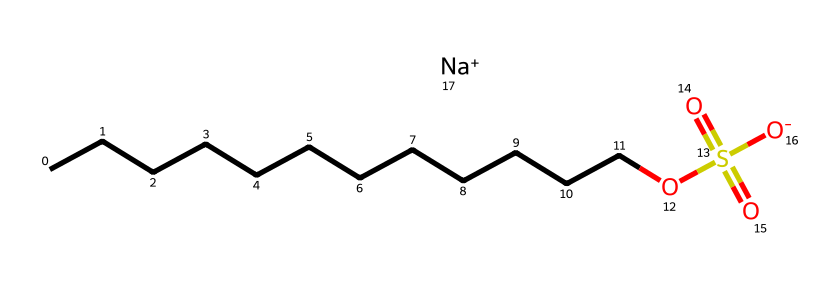What is the name of this chemical? The SMILES representation indicates that the chemical consists of a long carbon chain with a sulfate group and sodium ion. This structure corresponds to sodium lauryl sulfate, commonly used as a foaming agent in cosmetics.
Answer: sodium lauryl sulfate How many carbon atoms are in this molecule? By analyzing the carbon chain in the SMILES, we can count the number of 'C' symbols present in the longest chain, which totals to 12 carbon atoms in sodium lauryl sulfate.
Answer: 12 What functional group is present in this chemical? The presence of the sulfate group, indicated by 'OS(=O)(=O)', shows that the molecule contains a sulfonate functional group, commonly found in surfactants.
Answer: sulfonate What is the charge of the sodium ion in this chemical? The notation '[Na+]' in the SMILES indicates that the sodium ion has a positive charge, as shown by the '+' sign. The sodium contributes to the ionic nature of the compound.
Answer: +1 What property of this chemical contributes to its foaming ability? The long hydrocarbon tail (the linear carbon chain) combined with the hydrophilic head (the sulfate group) enables the molecule to lower surface tension, which is crucial for foaming action in cleansers.
Answer: surface tension Is this chemical considered anionic or cationic? The presence of a negatively charged sulfate group, in conjunction with the positive sodium ion, classifies sodium lauryl sulfate as an anionic surfactant.
Answer: anionic 